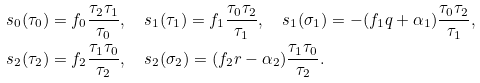<formula> <loc_0><loc_0><loc_500><loc_500>s _ { 0 } ( \tau _ { 0 } ) & = f _ { 0 } \frac { \tau _ { 2 } \tau _ { 1 } } { \tau _ { 0 } } , \quad s _ { 1 } ( \tau _ { 1 } ) = f _ { 1 } \frac { \tau _ { 0 } \tau _ { 2 } } { \tau _ { 1 } } , \quad s _ { 1 } ( \sigma _ { 1 } ) = - ( f _ { 1 } q + \alpha _ { 1 } ) \frac { \tau _ { 0 } \tau _ { 2 } } { \tau _ { 1 } } , \\ s _ { 2 } ( \tau _ { 2 } ) & = f _ { 2 } \frac { \tau _ { 1 } \tau _ { 0 } } { \tau _ { 2 } } , \quad s _ { 2 } ( \sigma _ { 2 } ) = ( f _ { 2 } r - \alpha _ { 2 } ) \frac { \tau _ { 1 } \tau _ { 0 } } { \tau _ { 2 } } .</formula> 